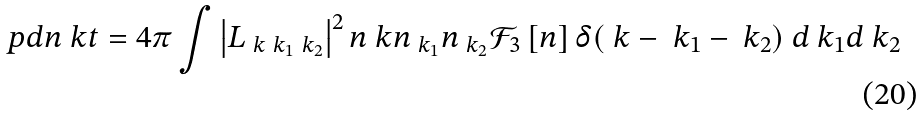Convert formula to latex. <formula><loc_0><loc_0><loc_500><loc_500>\ p d { n _ { \ } k } { t } = 4 \pi \int \left | L _ { \ k \ k _ { 1 } \ k _ { 2 } } \right | ^ { 2 } n _ { \ } k n _ { \ k _ { 1 } } n _ { \ k _ { 2 } } { \mathcal { F } } _ { 3 } \left [ n \right ] \delta ( \ k - \ k _ { 1 } - \ k _ { 2 } ) \ d \ k _ { 1 } d \ k _ { 2 }</formula> 